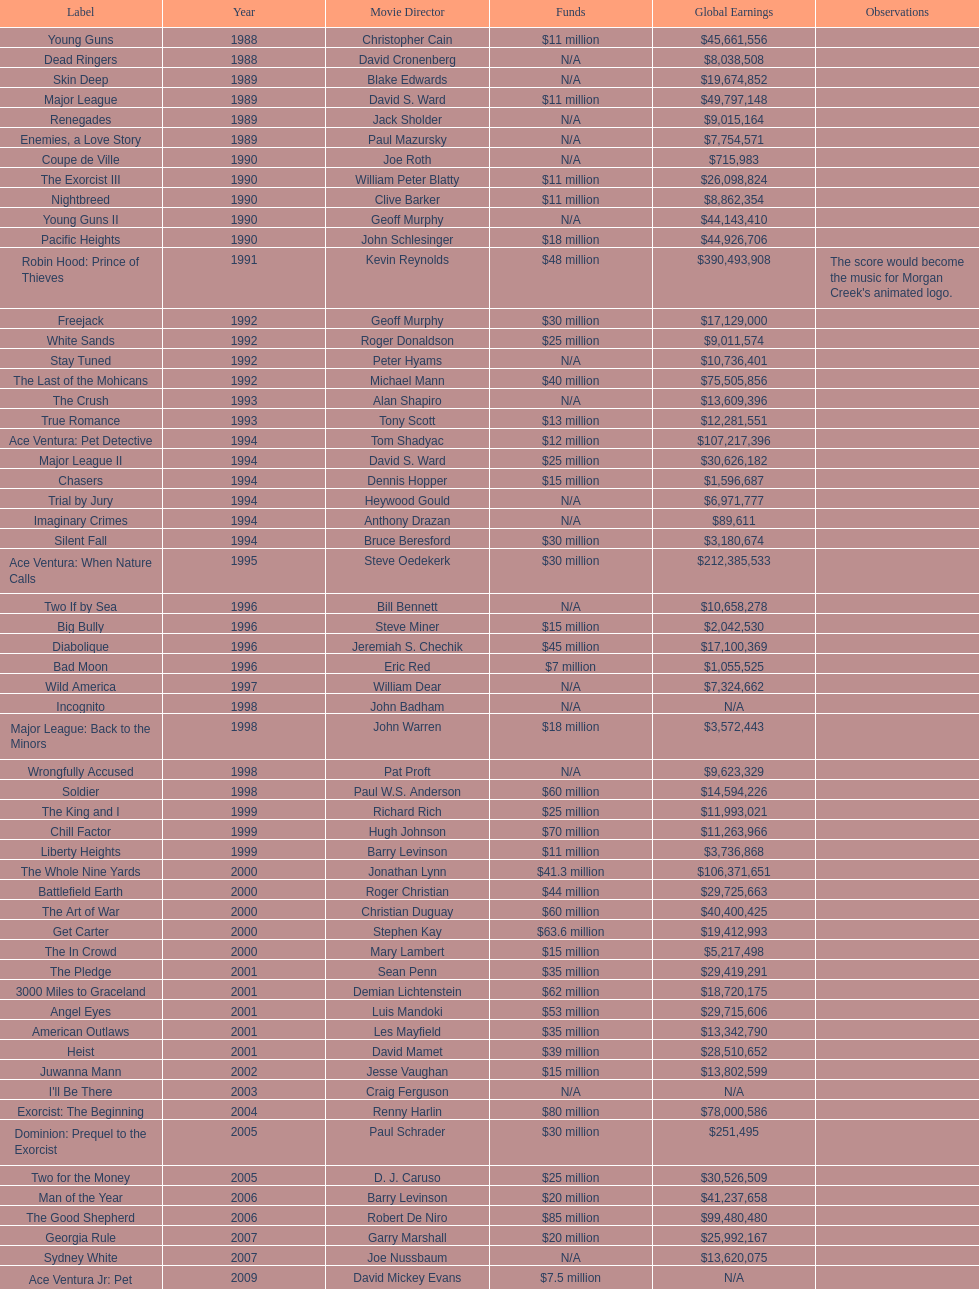Give me the full table as a dictionary. {'header': ['Label', 'Year', 'Movie Director', 'Funds', 'Global Earnings', 'Observations'], 'rows': [['Young Guns', '1988', 'Christopher Cain', '$11 million', '$45,661,556', ''], ['Dead Ringers', '1988', 'David Cronenberg', 'N/A', '$8,038,508', ''], ['Skin Deep', '1989', 'Blake Edwards', 'N/A', '$19,674,852', ''], ['Major League', '1989', 'David S. Ward', '$11 million', '$49,797,148', ''], ['Renegades', '1989', 'Jack Sholder', 'N/A', '$9,015,164', ''], ['Enemies, a Love Story', '1989', 'Paul Mazursky', 'N/A', '$7,754,571', ''], ['Coupe de Ville', '1990', 'Joe Roth', 'N/A', '$715,983', ''], ['The Exorcist III', '1990', 'William Peter Blatty', '$11 million', '$26,098,824', ''], ['Nightbreed', '1990', 'Clive Barker', '$11 million', '$8,862,354', ''], ['Young Guns II', '1990', 'Geoff Murphy', 'N/A', '$44,143,410', ''], ['Pacific Heights', '1990', 'John Schlesinger', '$18 million', '$44,926,706', ''], ['Robin Hood: Prince of Thieves', '1991', 'Kevin Reynolds', '$48 million', '$390,493,908', "The score would become the music for Morgan Creek's animated logo."], ['Freejack', '1992', 'Geoff Murphy', '$30 million', '$17,129,000', ''], ['White Sands', '1992', 'Roger Donaldson', '$25 million', '$9,011,574', ''], ['Stay Tuned', '1992', 'Peter Hyams', 'N/A', '$10,736,401', ''], ['The Last of the Mohicans', '1992', 'Michael Mann', '$40 million', '$75,505,856', ''], ['The Crush', '1993', 'Alan Shapiro', 'N/A', '$13,609,396', ''], ['True Romance', '1993', 'Tony Scott', '$13 million', '$12,281,551', ''], ['Ace Ventura: Pet Detective', '1994', 'Tom Shadyac', '$12 million', '$107,217,396', ''], ['Major League II', '1994', 'David S. Ward', '$25 million', '$30,626,182', ''], ['Chasers', '1994', 'Dennis Hopper', '$15 million', '$1,596,687', ''], ['Trial by Jury', '1994', 'Heywood Gould', 'N/A', '$6,971,777', ''], ['Imaginary Crimes', '1994', 'Anthony Drazan', 'N/A', '$89,611', ''], ['Silent Fall', '1994', 'Bruce Beresford', '$30 million', '$3,180,674', ''], ['Ace Ventura: When Nature Calls', '1995', 'Steve Oedekerk', '$30 million', '$212,385,533', ''], ['Two If by Sea', '1996', 'Bill Bennett', 'N/A', '$10,658,278', ''], ['Big Bully', '1996', 'Steve Miner', '$15 million', '$2,042,530', ''], ['Diabolique', '1996', 'Jeremiah S. Chechik', '$45 million', '$17,100,369', ''], ['Bad Moon', '1996', 'Eric Red', '$7 million', '$1,055,525', ''], ['Wild America', '1997', 'William Dear', 'N/A', '$7,324,662', ''], ['Incognito', '1998', 'John Badham', 'N/A', 'N/A', ''], ['Major League: Back to the Minors', '1998', 'John Warren', '$18 million', '$3,572,443', ''], ['Wrongfully Accused', '1998', 'Pat Proft', 'N/A', '$9,623,329', ''], ['Soldier', '1998', 'Paul W.S. Anderson', '$60 million', '$14,594,226', ''], ['The King and I', '1999', 'Richard Rich', '$25 million', '$11,993,021', ''], ['Chill Factor', '1999', 'Hugh Johnson', '$70 million', '$11,263,966', ''], ['Liberty Heights', '1999', 'Barry Levinson', '$11 million', '$3,736,868', ''], ['The Whole Nine Yards', '2000', 'Jonathan Lynn', '$41.3 million', '$106,371,651', ''], ['Battlefield Earth', '2000', 'Roger Christian', '$44 million', '$29,725,663', ''], ['The Art of War', '2000', 'Christian Duguay', '$60 million', '$40,400,425', ''], ['Get Carter', '2000', 'Stephen Kay', '$63.6 million', '$19,412,993', ''], ['The In Crowd', '2000', 'Mary Lambert', '$15 million', '$5,217,498', ''], ['The Pledge', '2001', 'Sean Penn', '$35 million', '$29,419,291', ''], ['3000 Miles to Graceland', '2001', 'Demian Lichtenstein', '$62 million', '$18,720,175', ''], ['Angel Eyes', '2001', 'Luis Mandoki', '$53 million', '$29,715,606', ''], ['American Outlaws', '2001', 'Les Mayfield', '$35 million', '$13,342,790', ''], ['Heist', '2001', 'David Mamet', '$39 million', '$28,510,652', ''], ['Juwanna Mann', '2002', 'Jesse Vaughan', '$15 million', '$13,802,599', ''], ["I'll Be There", '2003', 'Craig Ferguson', 'N/A', 'N/A', ''], ['Exorcist: The Beginning', '2004', 'Renny Harlin', '$80 million', '$78,000,586', ''], ['Dominion: Prequel to the Exorcist', '2005', 'Paul Schrader', '$30 million', '$251,495', ''], ['Two for the Money', '2005', 'D. J. Caruso', '$25 million', '$30,526,509', ''], ['Man of the Year', '2006', 'Barry Levinson', '$20 million', '$41,237,658', ''], ['The Good Shepherd', '2006', 'Robert De Niro', '$85 million', '$99,480,480', ''], ['Georgia Rule', '2007', 'Garry Marshall', '$20 million', '$25,992,167', ''], ['Sydney White', '2007', 'Joe Nussbaum', 'N/A', '$13,620,075', ''], ['Ace Ventura Jr: Pet Detective', '2009', 'David Mickey Evans', '$7.5 million', 'N/A', ''], ['Dream House', '2011', 'Jim Sheridan', '$50 million', '$38,502,340', ''], ['The Thing', '2011', 'Matthijs van Heijningen Jr.', '$38 million', '$27,428,670', ''], ['Tupac', '2014', 'Antoine Fuqua', '$45 million', '', '']]} What was the last movie morgan creek made for a budget under thirty million? Ace Ventura Jr: Pet Detective. 